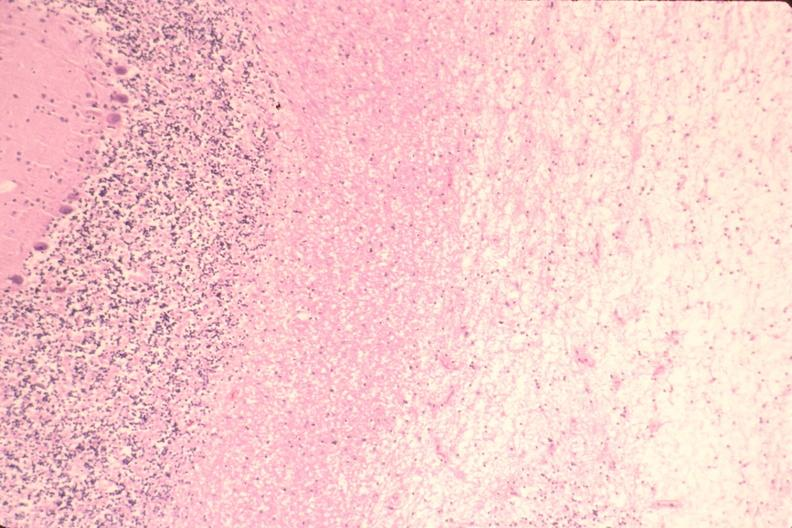s nervous present?
Answer the question using a single word or phrase. Yes 